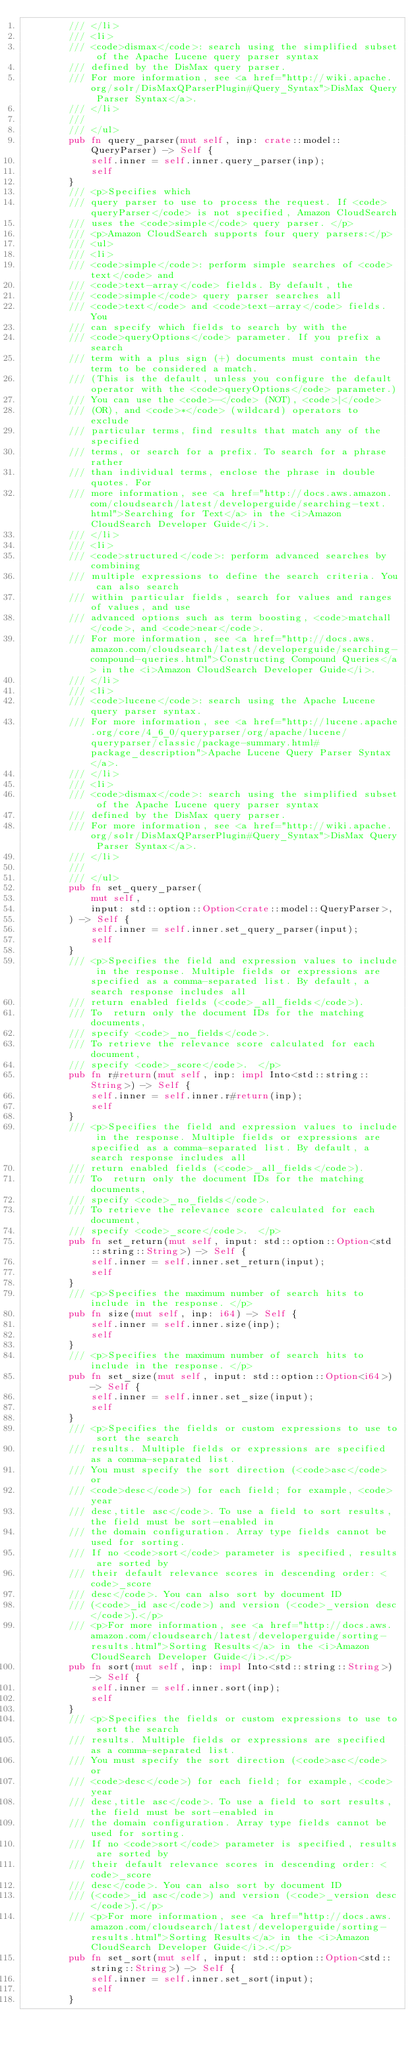<code> <loc_0><loc_0><loc_500><loc_500><_Rust_>        /// </li>
        /// <li>
        /// <code>dismax</code>: search using the simplified subset of the Apache Lucene query parser syntax
        /// defined by the DisMax query parser.
        /// For more information, see <a href="http://wiki.apache.org/solr/DisMaxQParserPlugin#Query_Syntax">DisMax Query Parser Syntax</a>.
        /// </li>
        ///
        /// </ul>
        pub fn query_parser(mut self, inp: crate::model::QueryParser) -> Self {
            self.inner = self.inner.query_parser(inp);
            self
        }
        /// <p>Specifies which
        /// query parser to use to process the request. If <code>queryParser</code> is not specified, Amazon CloudSearch
        /// uses the <code>simple</code> query parser. </p>
        /// <p>Amazon CloudSearch supports four query parsers:</p>
        /// <ul>
        /// <li>
        /// <code>simple</code>: perform simple searches of <code>text</code> and
        /// <code>text-array</code> fields. By default, the
        /// <code>simple</code> query parser searches all
        /// <code>text</code> and <code>text-array</code> fields. You
        /// can specify which fields to search by with the
        /// <code>queryOptions</code> parameter. If you prefix a search
        /// term with a plus sign (+) documents must contain the term to be considered a match.
        /// (This is the default, unless you configure the default operator with the <code>queryOptions</code> parameter.)
        /// You can use the <code>-</code> (NOT), <code>|</code>
        /// (OR), and <code>*</code> (wildcard) operators to exclude
        /// particular terms, find results that match any of the specified
        /// terms, or search for a prefix. To search for a phrase rather
        /// than individual terms, enclose the phrase in double quotes. For
        /// more information, see <a href="http://docs.aws.amazon.com/cloudsearch/latest/developerguide/searching-text.html">Searching for Text</a> in the <i>Amazon CloudSearch Developer Guide</i>.
        /// </li>
        /// <li>
        /// <code>structured</code>: perform advanced searches by combining
        /// multiple expressions to define the search criteria. You can also search
        /// within particular fields, search for values and ranges of values, and use
        /// advanced options such as term boosting, <code>matchall</code>, and <code>near</code>.
        /// For more information, see <a href="http://docs.aws.amazon.com/cloudsearch/latest/developerguide/searching-compound-queries.html">Constructing Compound Queries</a> in the <i>Amazon CloudSearch Developer Guide</i>.
        /// </li>
        /// <li>
        /// <code>lucene</code>: search using the Apache Lucene query parser syntax.
        /// For more information, see <a href="http://lucene.apache.org/core/4_6_0/queryparser/org/apache/lucene/queryparser/classic/package-summary.html#package_description">Apache Lucene Query Parser Syntax</a>.
        /// </li>
        /// <li>
        /// <code>dismax</code>: search using the simplified subset of the Apache Lucene query parser syntax
        /// defined by the DisMax query parser.
        /// For more information, see <a href="http://wiki.apache.org/solr/DisMaxQParserPlugin#Query_Syntax">DisMax Query Parser Syntax</a>.
        /// </li>
        ///
        /// </ul>
        pub fn set_query_parser(
            mut self,
            input: std::option::Option<crate::model::QueryParser>,
        ) -> Self {
            self.inner = self.inner.set_query_parser(input);
            self
        }
        /// <p>Specifies the field and expression values to include in the response. Multiple fields or expressions are specified as a comma-separated list. By default, a search response includes all
        /// return enabled fields (<code>_all_fields</code>).
        /// To  return only the document IDs for the matching documents,
        /// specify <code>_no_fields</code>.
        /// To retrieve the relevance score calculated for each document,
        /// specify <code>_score</code>.  </p>
        pub fn r#return(mut self, inp: impl Into<std::string::String>) -> Self {
            self.inner = self.inner.r#return(inp);
            self
        }
        /// <p>Specifies the field and expression values to include in the response. Multiple fields or expressions are specified as a comma-separated list. By default, a search response includes all
        /// return enabled fields (<code>_all_fields</code>).
        /// To  return only the document IDs for the matching documents,
        /// specify <code>_no_fields</code>.
        /// To retrieve the relevance score calculated for each document,
        /// specify <code>_score</code>.  </p>
        pub fn set_return(mut self, input: std::option::Option<std::string::String>) -> Self {
            self.inner = self.inner.set_return(input);
            self
        }
        /// <p>Specifies the maximum number of search hits to include in the response. </p>
        pub fn size(mut self, inp: i64) -> Self {
            self.inner = self.inner.size(inp);
            self
        }
        /// <p>Specifies the maximum number of search hits to include in the response. </p>
        pub fn set_size(mut self, input: std::option::Option<i64>) -> Self {
            self.inner = self.inner.set_size(input);
            self
        }
        /// <p>Specifies the fields or custom expressions to use to sort the search
        /// results. Multiple fields or expressions are specified as a comma-separated list.
        /// You must specify the sort direction (<code>asc</code> or
        /// <code>desc</code>) for each field; for example, <code>year
        /// desc,title asc</code>. To use a field to sort results, the field must be sort-enabled in
        /// the domain configuration. Array type fields cannot be used for sorting.
        /// If no <code>sort</code> parameter is specified, results are sorted by
        /// their default relevance scores in descending order: <code>_score
        /// desc</code>. You can also sort by document ID
        /// (<code>_id asc</code>) and version (<code>_version desc</code>).</p>
        /// <p>For more information, see <a href="http://docs.aws.amazon.com/cloudsearch/latest/developerguide/sorting-results.html">Sorting Results</a> in the <i>Amazon CloudSearch Developer Guide</i>.</p>
        pub fn sort(mut self, inp: impl Into<std::string::String>) -> Self {
            self.inner = self.inner.sort(inp);
            self
        }
        /// <p>Specifies the fields or custom expressions to use to sort the search
        /// results. Multiple fields or expressions are specified as a comma-separated list.
        /// You must specify the sort direction (<code>asc</code> or
        /// <code>desc</code>) for each field; for example, <code>year
        /// desc,title asc</code>. To use a field to sort results, the field must be sort-enabled in
        /// the domain configuration. Array type fields cannot be used for sorting.
        /// If no <code>sort</code> parameter is specified, results are sorted by
        /// their default relevance scores in descending order: <code>_score
        /// desc</code>. You can also sort by document ID
        /// (<code>_id asc</code>) and version (<code>_version desc</code>).</p>
        /// <p>For more information, see <a href="http://docs.aws.amazon.com/cloudsearch/latest/developerguide/sorting-results.html">Sorting Results</a> in the <i>Amazon CloudSearch Developer Guide</i>.</p>
        pub fn set_sort(mut self, input: std::option::Option<std::string::String>) -> Self {
            self.inner = self.inner.set_sort(input);
            self
        }</code> 